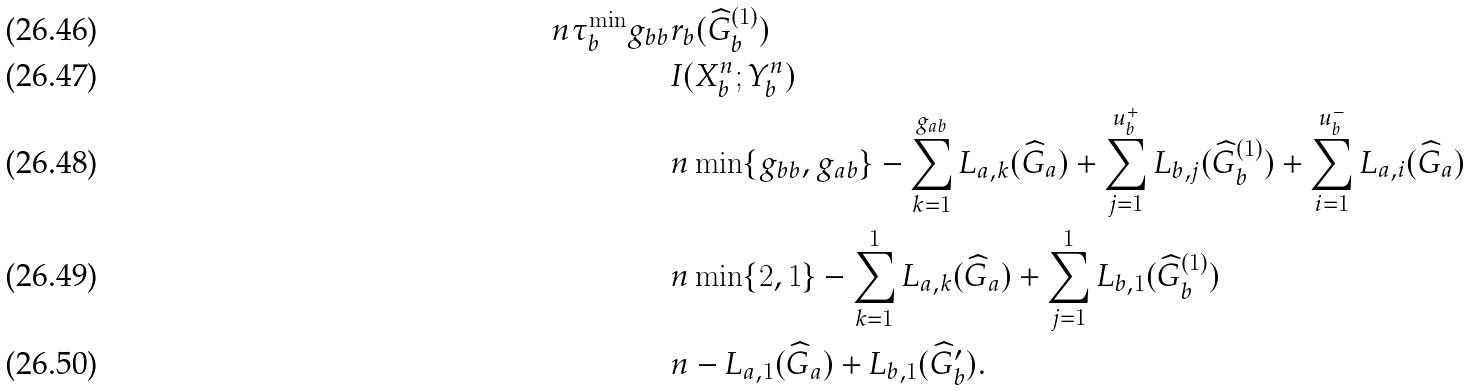Convert formula to latex. <formula><loc_0><loc_0><loc_500><loc_500>n \tau _ { b } ^ { \min } g _ { b b } & r _ { b } ( \widehat { G } _ { b } ^ { ( 1 ) } ) \\ & I ( X _ { b } ^ { n } ; Y _ { b } ^ { n } ) \\ & n \min \{ g _ { b b } , g _ { a b } \} - \sum _ { k = 1 } ^ { g _ { a b } } L _ { a , k } ( \widehat { G } _ { a } ) + \sum _ { j = 1 } ^ { u _ { b } ^ { + } } L _ { b , j } ( \widehat { G } _ { b } ^ { ( 1 ) } ) + \sum _ { i = 1 } ^ { u _ { b } ^ { - } } L _ { a , i } ( \widehat { G } _ { a } ) \\ & n \min \{ 2 , 1 \} - \sum _ { k = 1 } ^ { 1 } L _ { a , k } ( \widehat { G } _ { a } ) + \sum _ { j = 1 } ^ { 1 } L _ { b , 1 } ( \widehat { G } _ { b } ^ { ( 1 ) } ) \\ & n - L _ { a , 1 } ( \widehat { G } _ { a } ) + L _ { b , 1 } ( \widehat { G } _ { b } ^ { \prime } ) .</formula> 